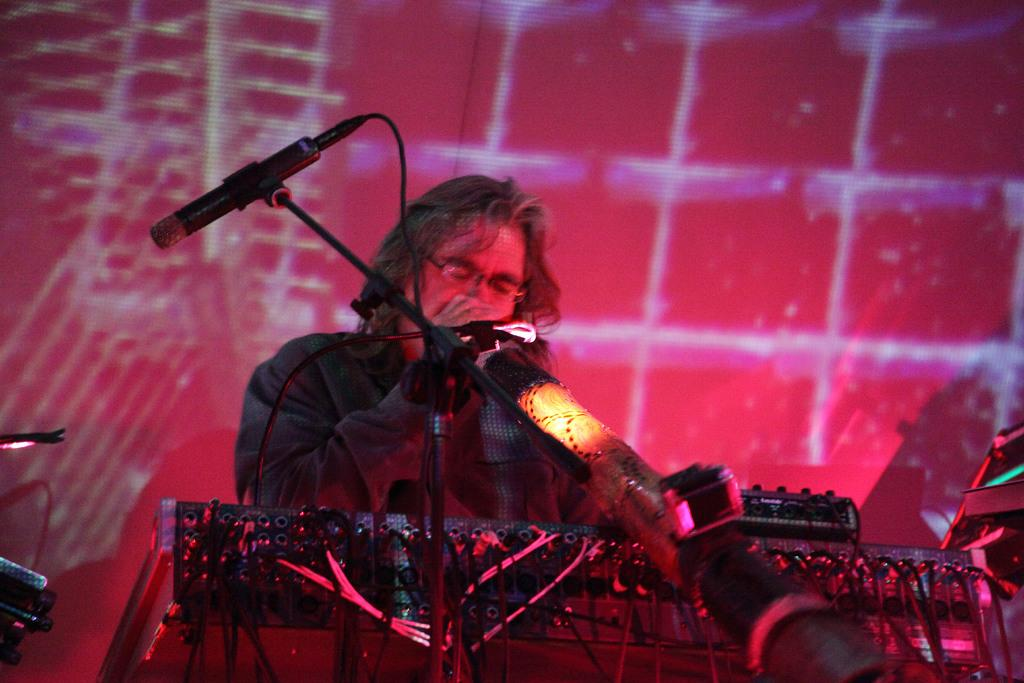What is the person in the image doing? The person is playing a musical instrument in the image. What is the microphone in the image attached to? The microphone is attached to a stand in the image. What can be seen in the background of the image? There are lights visible in the background of the image. What type of holiday is being celebrated in the image? There is no indication of a holiday being celebrated in the image. Can you tell me where the nearest hydrant is located in the image? There is no hydrant present in the image. 